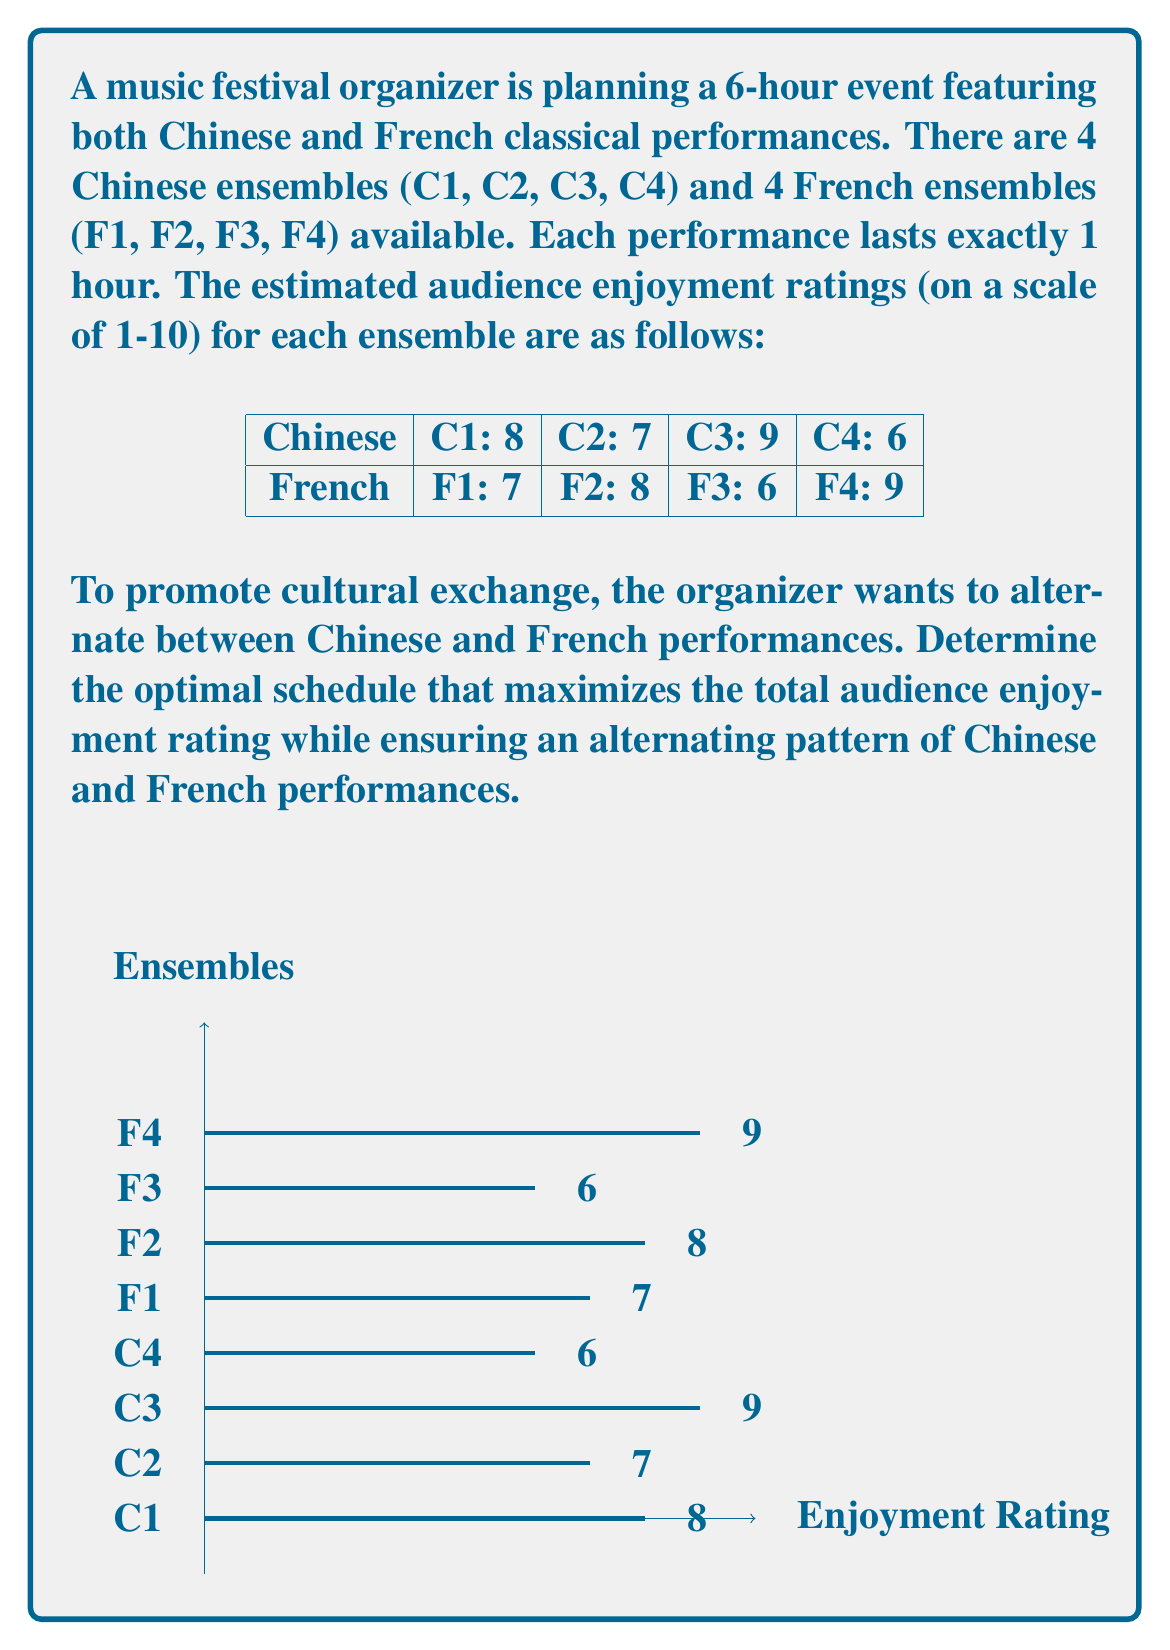Could you help me with this problem? To solve this problem, we can use a dynamic programming approach. Let's break it down step-by-step:

1) First, we need to create two arrays, one for Chinese performances and one for French performances, sorted by their ratings in descending order:

   Chinese: [C3 (9), C1 (8), C2 (7), C4 (6)]
   French: [F4 (9), F2 (8), F1 (7), F3 (6)]

2) Since we need to alternate between Chinese and French performances, and we have 6 hours, we'll need to select 3 Chinese and 3 French performances.

3) To maximize the total enjoyment, we should always choose the highest-rated available performance from each category.

4) The optimal schedule will be:

   Hour 1: C3 (9)
   Hour 2: F4 (9)
   Hour 3: C1 (8)
   Hour 4: F2 (8)
   Hour 5: C2 (7)
   Hour 6: F1 (7)

5) To calculate the total enjoyment rating, we sum up the ratings:

   $$ \text{Total Enjoyment} = 9 + 9 + 8 + 8 + 7 + 7 = 48 $$

Therefore, the optimal schedule achieves a total audience enjoyment rating of 48.
Answer: C3, F4, C1, F2, C2, F1; Total rating: 48 